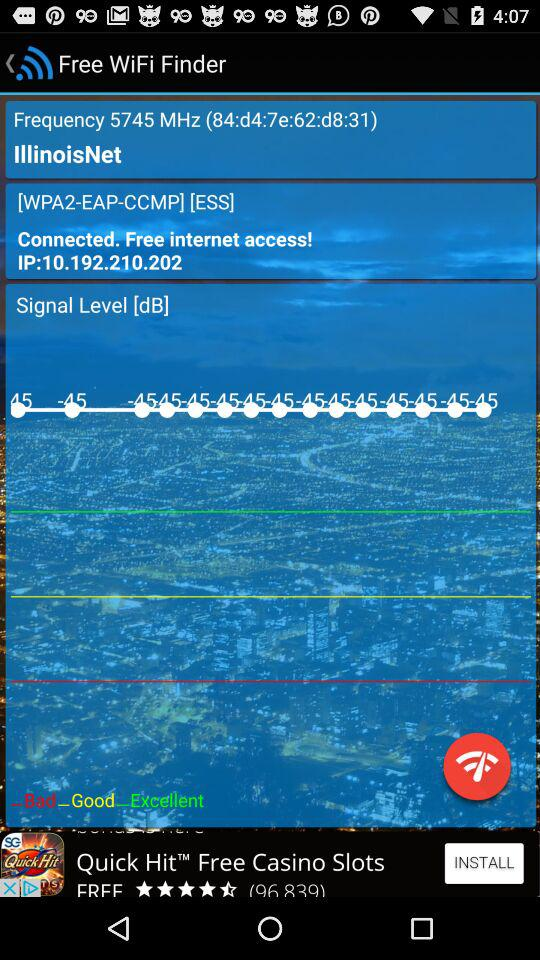What is the frequency of WiFi? The frequency is 5754 MHz. 